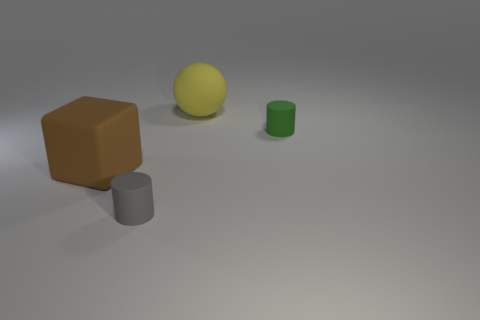How many things are both in front of the big sphere and behind the brown rubber object?
Offer a terse response. 1. What is the brown thing made of?
Offer a terse response. Rubber. The brown object that is the same size as the yellow sphere is what shape?
Offer a terse response. Cube. Are the large thing in front of the big yellow rubber sphere and the small object that is in front of the brown rubber cube made of the same material?
Offer a terse response. Yes. How many matte objects are there?
Make the answer very short. 4. How many other small objects are the same shape as the gray matte object?
Provide a short and direct response. 1. Is the shape of the small green thing the same as the gray thing?
Offer a very short reply. Yes. The yellow rubber thing is what size?
Provide a short and direct response. Large. How many green rubber cylinders are the same size as the gray cylinder?
Provide a short and direct response. 1. Is the size of the cylinder that is to the left of the yellow matte object the same as the rubber cylinder behind the large block?
Provide a short and direct response. Yes. 